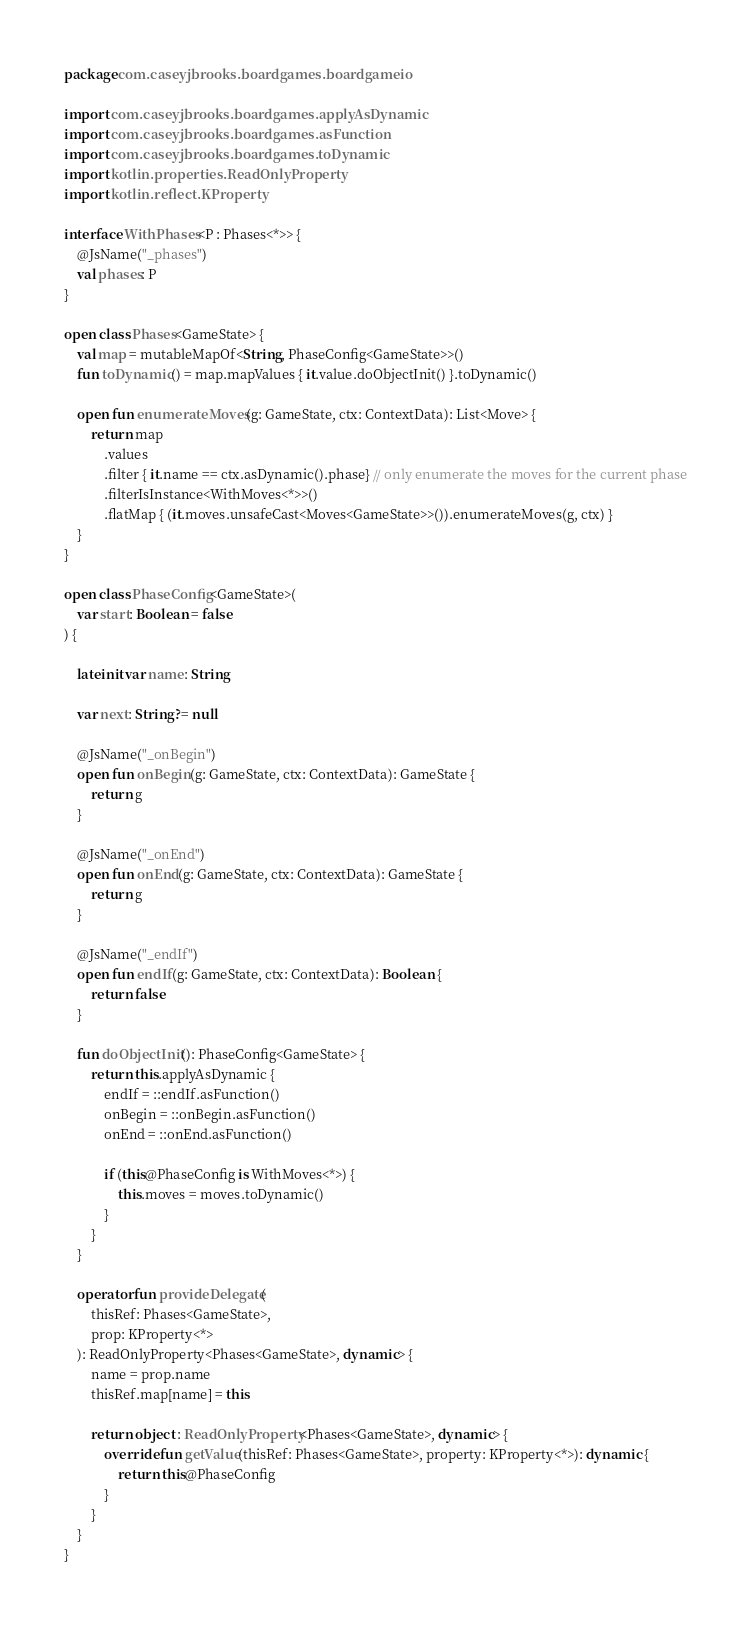Convert code to text. <code><loc_0><loc_0><loc_500><loc_500><_Kotlin_>package com.caseyjbrooks.boardgames.boardgameio

import com.caseyjbrooks.boardgames.applyAsDynamic
import com.caseyjbrooks.boardgames.asFunction
import com.caseyjbrooks.boardgames.toDynamic
import kotlin.properties.ReadOnlyProperty
import kotlin.reflect.KProperty

interface WithPhases<P : Phases<*>> {
    @JsName("_phases")
    val phases: P
}

open class Phases<GameState> {
    val map = mutableMapOf<String, PhaseConfig<GameState>>()
    fun toDynamic() = map.mapValues { it.value.doObjectInit() }.toDynamic()

    open fun enumerateMoves(g: GameState, ctx: ContextData): List<Move> {
        return map
            .values
            .filter { it.name == ctx.asDynamic().phase} // only enumerate the moves for the current phase
            .filterIsInstance<WithMoves<*>>()
            .flatMap { (it.moves.unsafeCast<Moves<GameState>>()).enumerateMoves(g, ctx) }
    }
}

open class PhaseConfig<GameState>(
    var start: Boolean = false
) {

    lateinit var name: String

    var next: String? = null

    @JsName("_onBegin")
    open fun onBegin(g: GameState, ctx: ContextData): GameState {
        return g
    }

    @JsName("_onEnd")
    open fun onEnd(g: GameState, ctx: ContextData): GameState {
        return g
    }

    @JsName("_endIf")
    open fun endIf(g: GameState, ctx: ContextData): Boolean {
        return false
    }

    fun doObjectInit(): PhaseConfig<GameState> {
        return this.applyAsDynamic {
            endIf = ::endIf.asFunction()
            onBegin = ::onBegin.asFunction()
            onEnd = ::onEnd.asFunction()

            if (this@PhaseConfig is WithMoves<*>) {
                this.moves = moves.toDynamic()
            }
        }
    }

    operator fun provideDelegate(
        thisRef: Phases<GameState>,
        prop: KProperty<*>
    ): ReadOnlyProperty<Phases<GameState>, dynamic> {
        name = prop.name
        thisRef.map[name] = this

        return object : ReadOnlyProperty<Phases<GameState>, dynamic> {
            override fun getValue(thisRef: Phases<GameState>, property: KProperty<*>): dynamic {
                return this@PhaseConfig
            }
        }
    }
}
</code> 